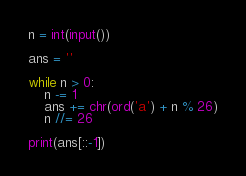<code> <loc_0><loc_0><loc_500><loc_500><_Python_>n = int(input())

ans = ''

while n > 0:
    n -= 1
    ans += chr(ord('a') + n % 26)
    n //= 26

print(ans[::-1])
</code> 